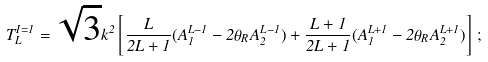<formula> <loc_0><loc_0><loc_500><loc_500>T _ { L } ^ { I = 1 } = \sqrt { 3 } { k } ^ { 2 } \left [ \frac { L } { 2 L + 1 } ( A _ { 1 } ^ { L - 1 } - 2 \theta _ { R } A _ { 2 } ^ { L - 1 } ) + \frac { L + 1 } { 2 L + 1 } ( A _ { 1 } ^ { L + 1 } - 2 \theta _ { R } A _ { 2 } ^ { L + 1 } ) \right ] \, ;</formula> 